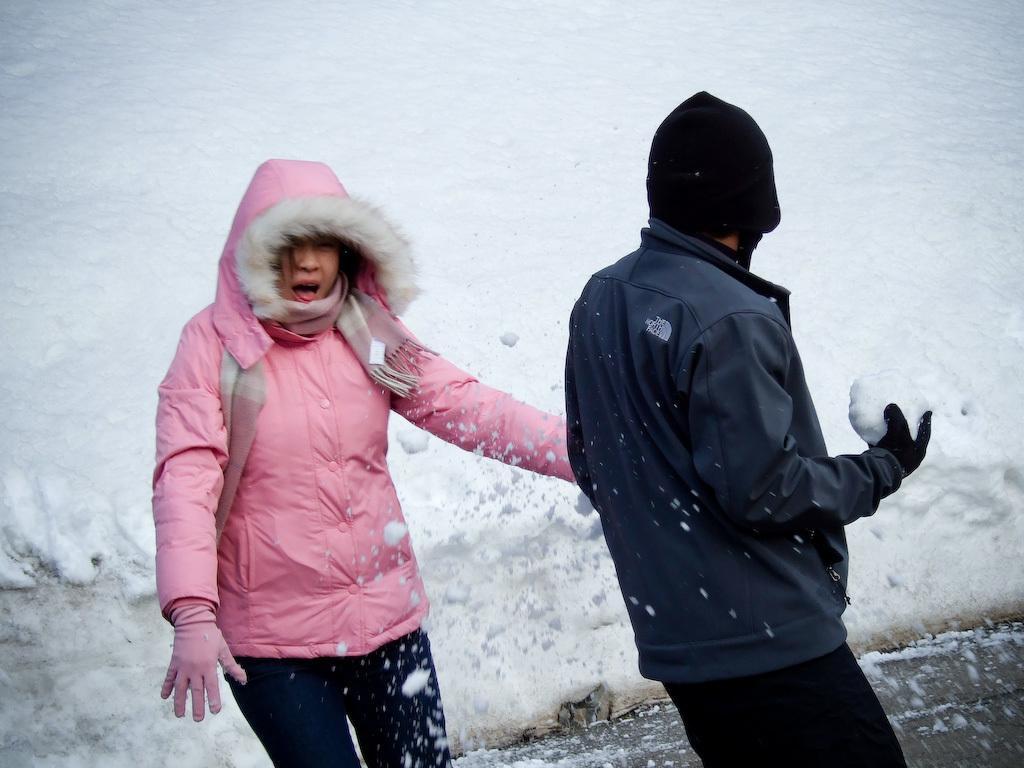Describe this image in one or two sentences. In the center of the image we can see a man and a lady standing. In the background there is sky. 